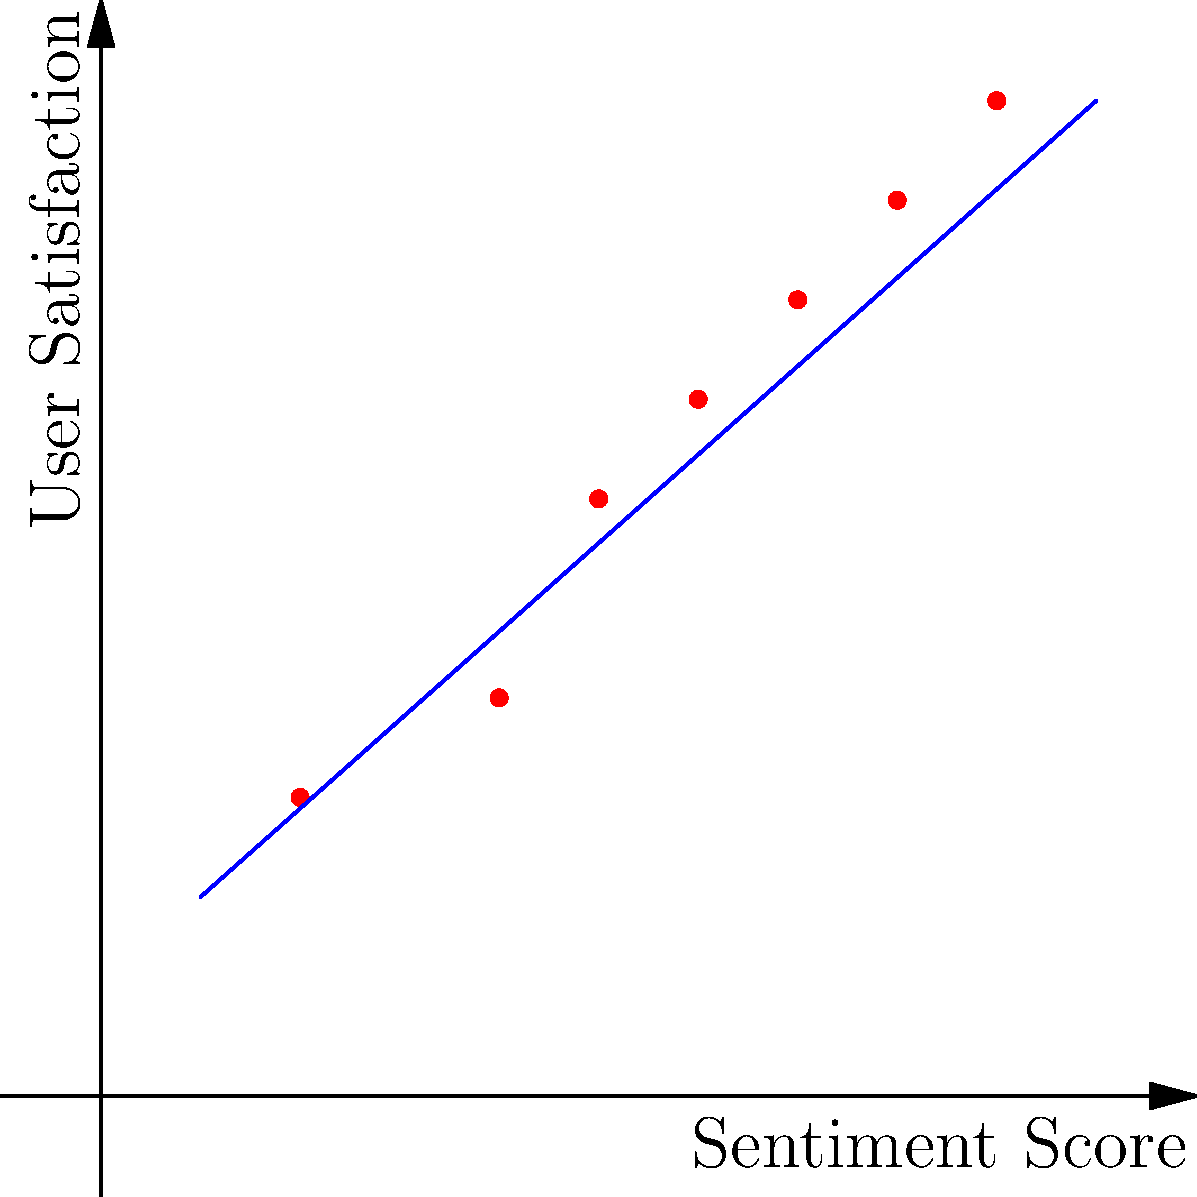Based on the scatter plot showing the relationship between sentiment scores and user satisfaction ratings, what can you conclude about the correlation between these two variables, and how might this insight inform the enhancement of the sentiment analysis model? To answer this question, let's analyze the scatter plot step-by-step:

1. Observe the overall pattern:
   The points generally follow an upward trend from left to right.

2. Assess the correlation:
   There appears to be a strong positive correlation between sentiment scores and user satisfaction ratings.

3. Interpret the correlation:
   As sentiment scores increase, user satisfaction ratings tend to increase as well.

4. Evaluate the strength of the relationship:
   The points are closely clustered around an imaginary straight line, indicating a strong linear relationship.

5. Consider outliers:
   There don't appear to be any significant outliers that deviate from the general trend.

6. Implications for the sentiment analysis model:
   - The strong positive correlation suggests that the current sentiment analysis model is effectively capturing user satisfaction.
   - The model could potentially be used to predict user satisfaction based on sentiment scores.
   - Areas for improvement might include focusing on refining the model's accuracy in the mid-range scores, where there's slightly more variance in the relationship.

7. Potential enhancements:
   - Incorporate additional features that might explain the slight variations in user satisfaction for similar sentiment scores.
   - Explore non-linear models to capture any subtle curvature in the relationship that a linear model might miss.
   - Collect more data points to increase confidence in the observed relationship and potentially reveal more nuanced patterns.
Answer: Strong positive correlation; model effectively captures user satisfaction but can be refined for mid-range scores and explored for non-linear relationships. 